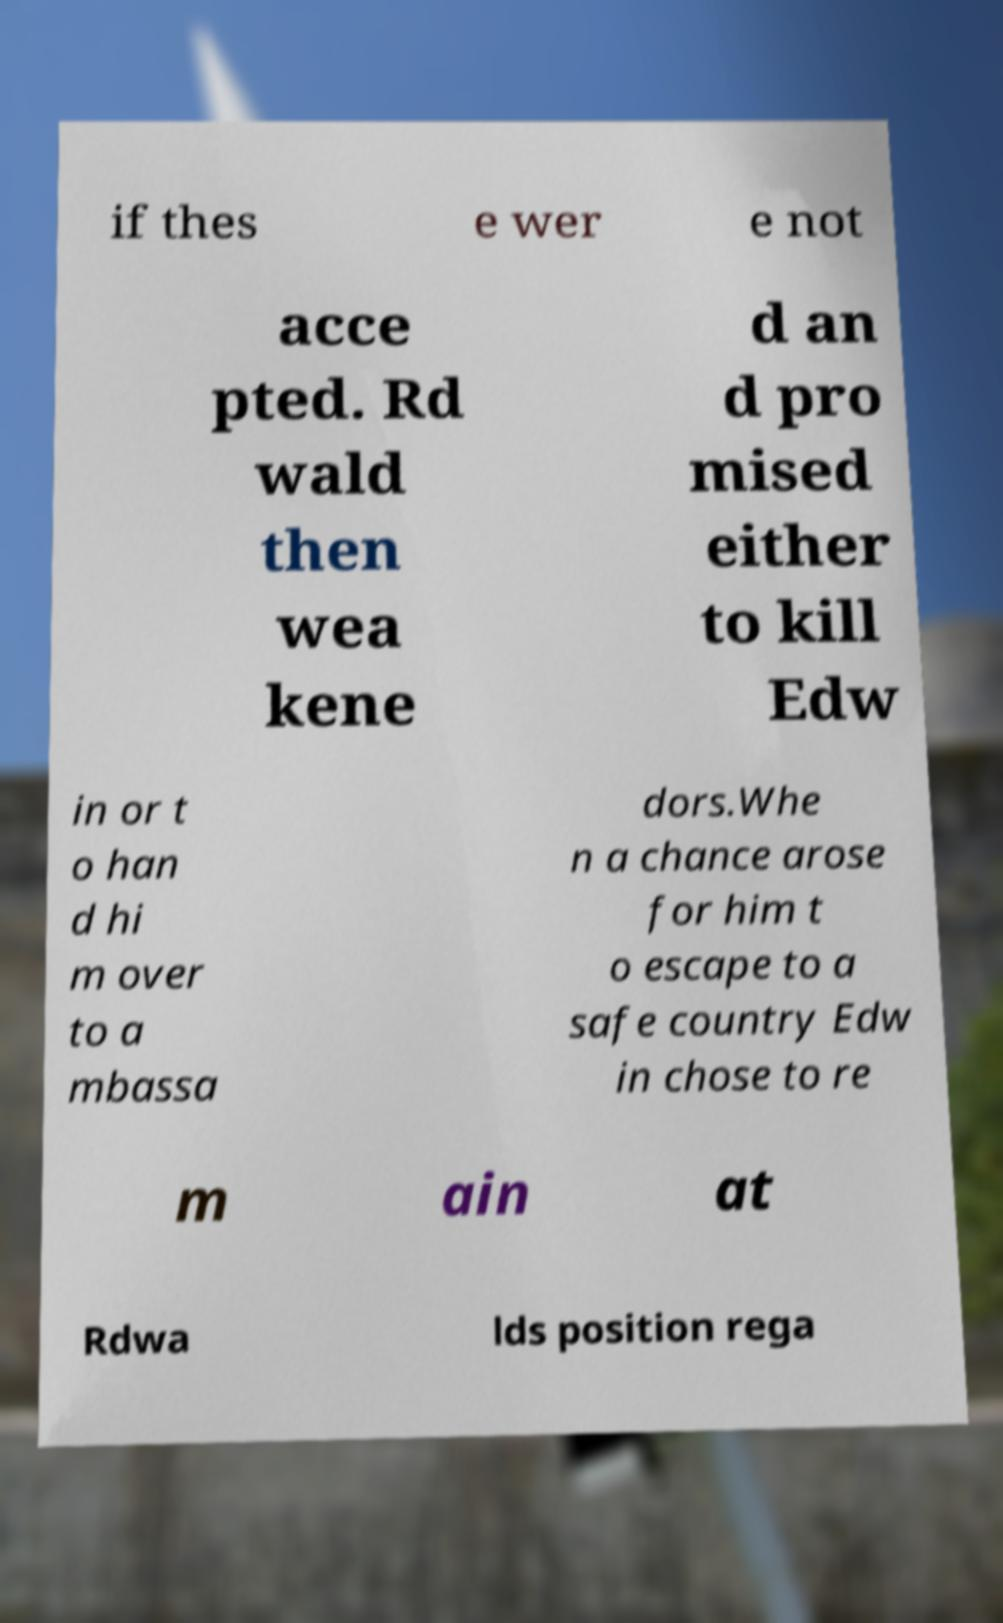There's text embedded in this image that I need extracted. Can you transcribe it verbatim? if thes e wer e not acce pted. Rd wald then wea kene d an d pro mised either to kill Edw in or t o han d hi m over to a mbassa dors.Whe n a chance arose for him t o escape to a safe country Edw in chose to re m ain at Rdwa lds position rega 